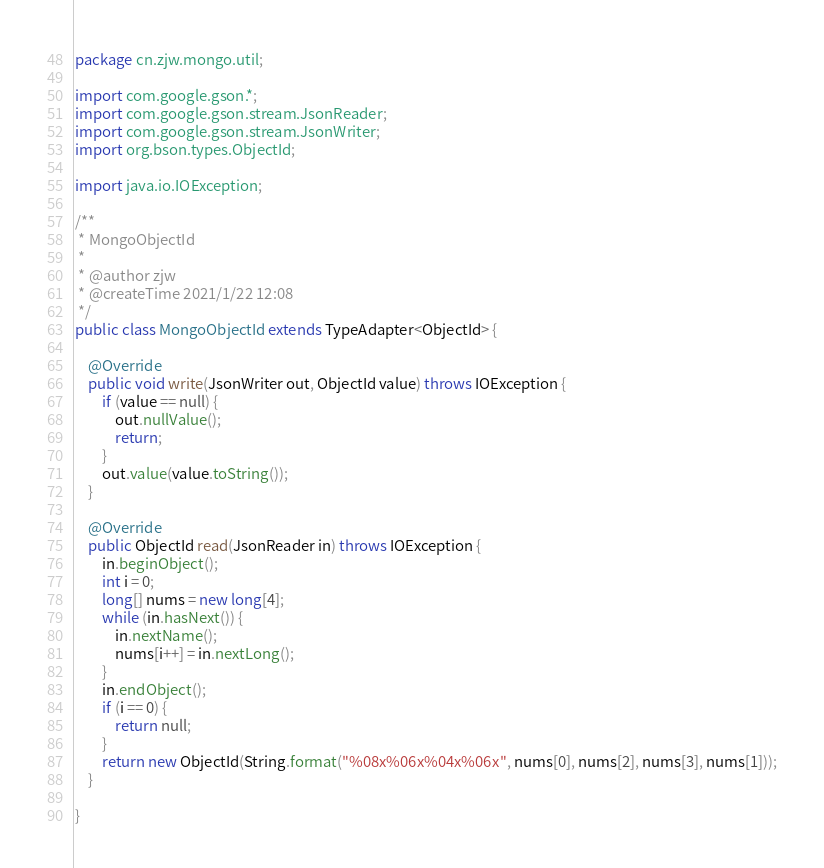Convert code to text. <code><loc_0><loc_0><loc_500><loc_500><_Java_>package cn.zjw.mongo.util;

import com.google.gson.*;
import com.google.gson.stream.JsonReader;
import com.google.gson.stream.JsonWriter;
import org.bson.types.ObjectId;

import java.io.IOException;

/**
 * MongoObjectId
 *
 * @author zjw
 * @createTime 2021/1/22 12:08
 */
public class MongoObjectId extends TypeAdapter<ObjectId> {

    @Override
    public void write(JsonWriter out, ObjectId value) throws IOException {
        if (value == null) {
            out.nullValue();
            return;
        }
        out.value(value.toString());
    }

    @Override
    public ObjectId read(JsonReader in) throws IOException {
        in.beginObject();
        int i = 0;
        long[] nums = new long[4];
        while (in.hasNext()) {
            in.nextName();
            nums[i++] = in.nextLong();
        }
        in.endObject();
        if (i == 0) {
            return null;
        }
        return new ObjectId(String.format("%08x%06x%04x%06x", nums[0], nums[2], nums[3], nums[1]));
    }

}
</code> 